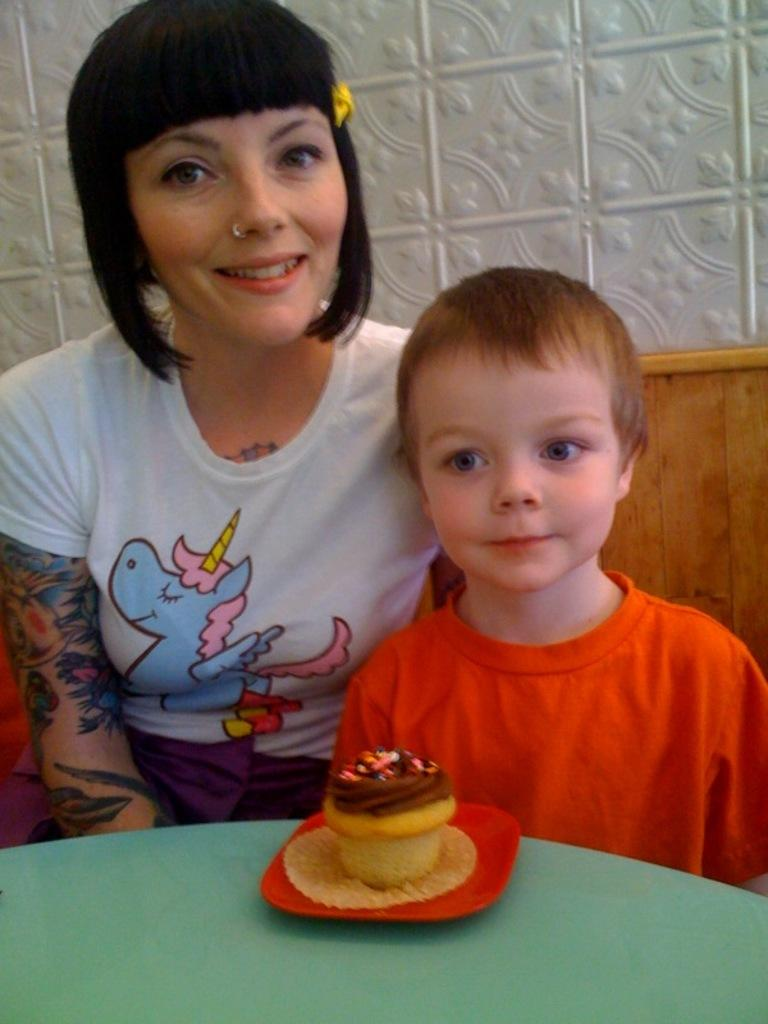Who are the people in the image? There is a woman and a boy in the image. What is the woman doing in the image? The woman is smiling in the image. What is in front of the woman and the boy? There is a cupcake in front of them. What type of ship can be seen in the background of the image? There is no ship present in the image; it only features a woman, a boy, and a cupcake. Who is the woman's friend in the image? The provided facts do not mention any friends or relationships between the people in the image. 